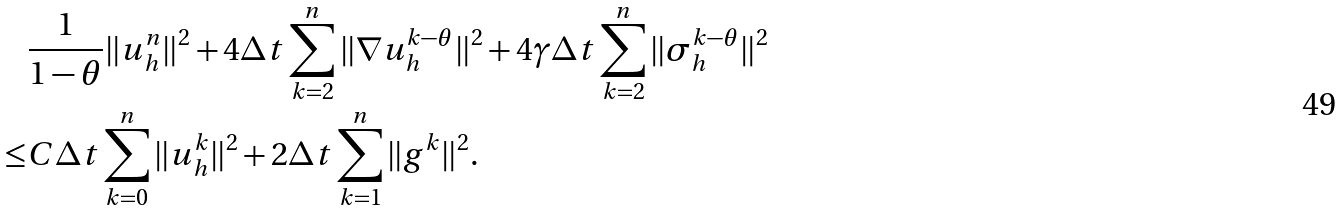Convert formula to latex. <formula><loc_0><loc_0><loc_500><loc_500>& \frac { 1 } { 1 - \theta } \| u _ { h } ^ { n } \| ^ { 2 } + 4 \Delta t \sum _ { k = 2 } ^ { n } \| \nabla u _ { h } ^ { k - \theta } \| ^ { 2 } + 4 \gamma \Delta t \sum _ { k = 2 } ^ { n } \| \sigma _ { h } ^ { k - \theta } \| ^ { 2 } \\ \leq & C \Delta t \sum _ { k = 0 } ^ { n } \| u _ { h } ^ { k } \| ^ { 2 } + 2 \Delta t \sum _ { k = 1 } ^ { n } \| g ^ { k } \| ^ { 2 } .</formula> 